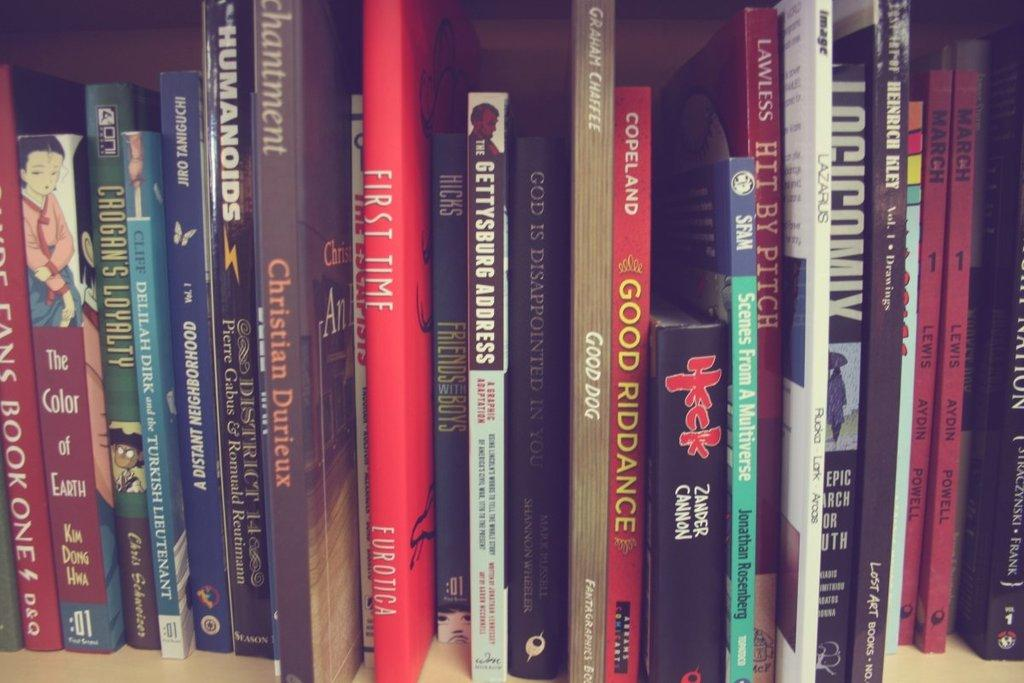<image>
Share a concise interpretation of the image provided. a red book called Good Riddance among others 